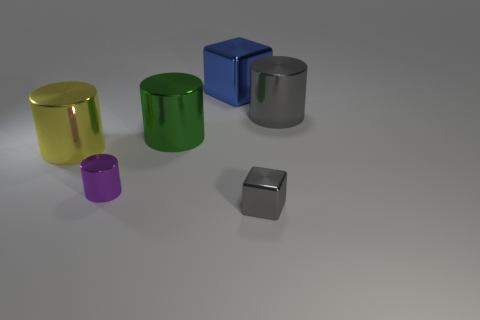Subtract all gray cylinders. How many cylinders are left? 3 Add 2 large green matte cylinders. How many objects exist? 8 Subtract all cubes. How many objects are left? 4 Subtract 1 blocks. How many blocks are left? 1 Subtract all yellow cylinders. How many cylinders are left? 3 Subtract 0 red cubes. How many objects are left? 6 Subtract all blue cubes. Subtract all red spheres. How many cubes are left? 1 Subtract all green cylinders. How many gray blocks are left? 1 Subtract all small yellow matte objects. Subtract all big blue objects. How many objects are left? 5 Add 1 large blue metallic blocks. How many large blue metallic blocks are left? 2 